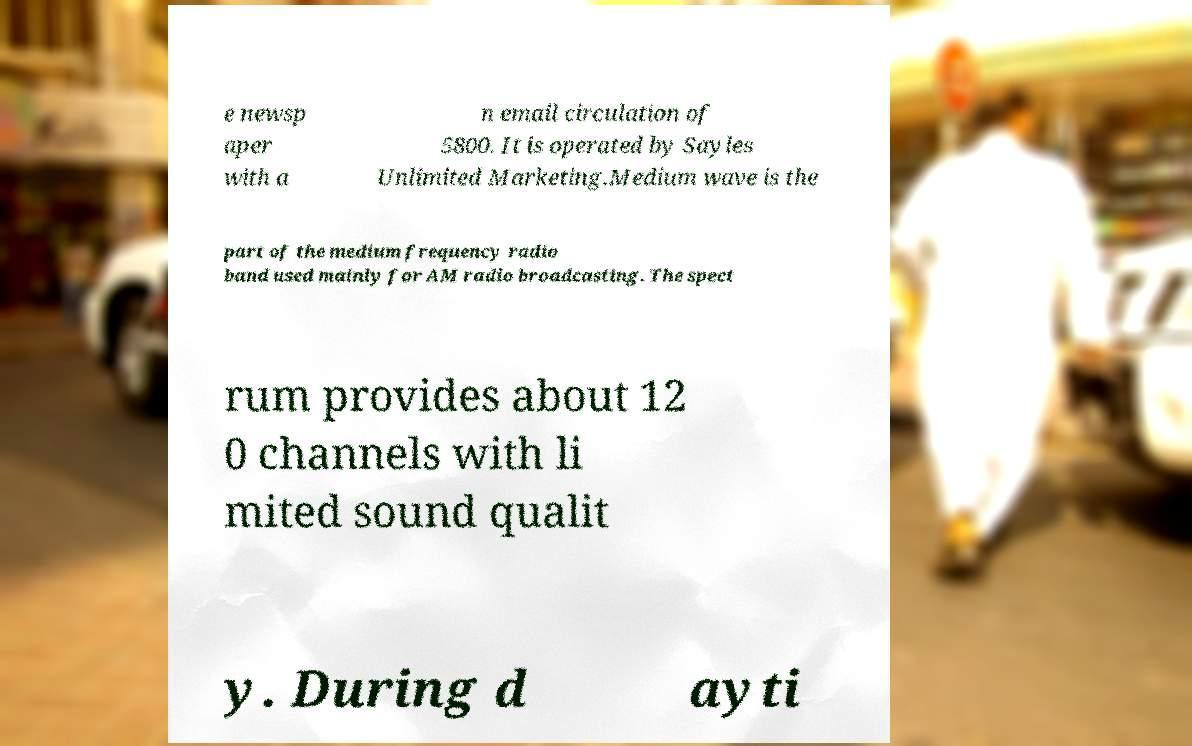Could you extract and type out the text from this image? e newsp aper with a n email circulation of 5800. It is operated by Sayles Unlimited Marketing.Medium wave is the part of the medium frequency radio band used mainly for AM radio broadcasting. The spect rum provides about 12 0 channels with li mited sound qualit y. During d ayti 